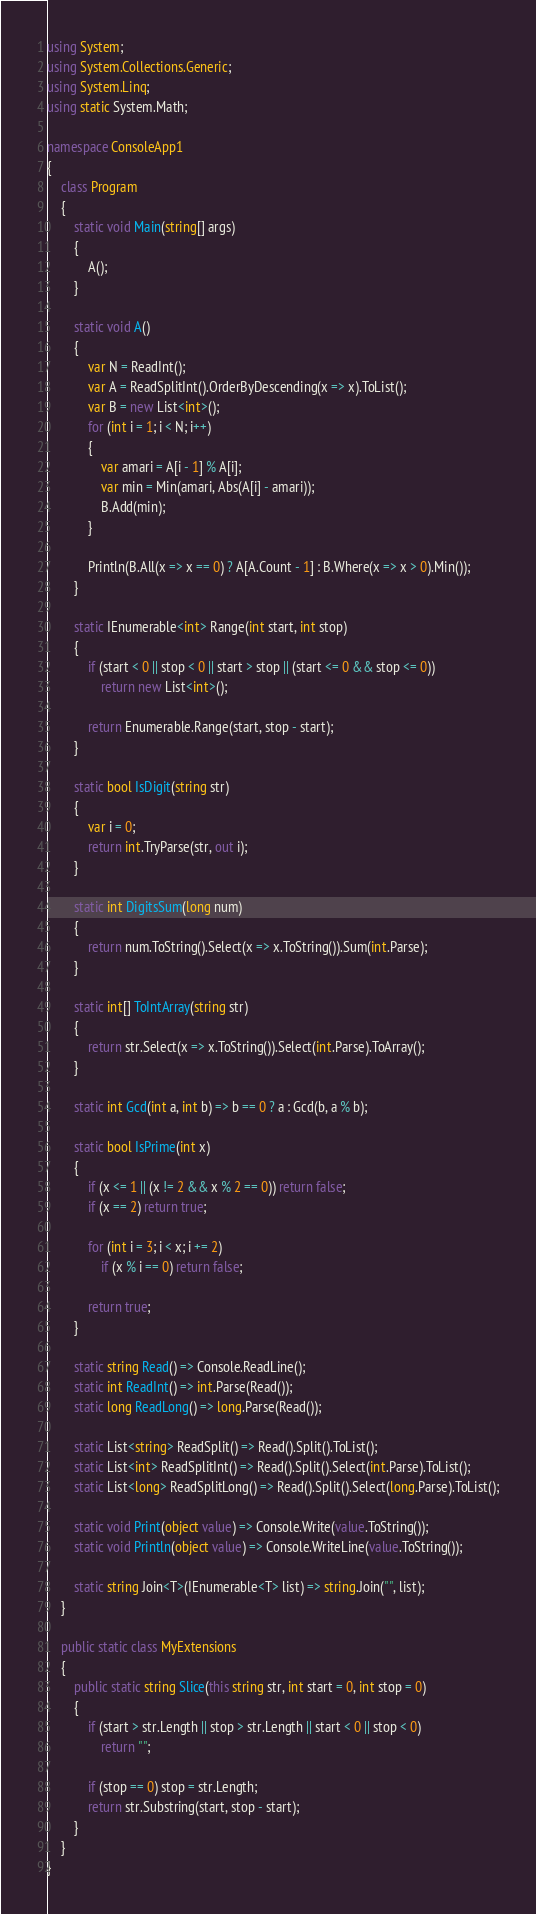Convert code to text. <code><loc_0><loc_0><loc_500><loc_500><_C#_>using System;
using System.Collections.Generic;
using System.Linq;
using static System.Math;

namespace ConsoleApp1
{
    class Program
    {
        static void Main(string[] args)
        {
            A();
        }

        static void A()
        {
            var N = ReadInt();
            var A = ReadSplitInt().OrderByDescending(x => x).ToList();
            var B = new List<int>();
            for (int i = 1; i < N; i++)
            {
                var amari = A[i - 1] % A[i];
                var min = Min(amari, Abs(A[i] - amari));
                B.Add(min);
            }

            Println(B.All(x => x == 0) ? A[A.Count - 1] : B.Where(x => x > 0).Min());
        }

        static IEnumerable<int> Range(int start, int stop)
        {
            if (start < 0 || stop < 0 || start > stop || (start <= 0 && stop <= 0))
                return new List<int>();

            return Enumerable.Range(start, stop - start);
        }

        static bool IsDigit(string str)
        {
            var i = 0;
            return int.TryParse(str, out i);
        }

        static int DigitsSum(long num)
        {
            return num.ToString().Select(x => x.ToString()).Sum(int.Parse);
        }

        static int[] ToIntArray(string str)
        {
            return str.Select(x => x.ToString()).Select(int.Parse).ToArray();
        }

        static int Gcd(int a, int b) => b == 0 ? a : Gcd(b, a % b);

        static bool IsPrime(int x)
        {
            if (x <= 1 || (x != 2 && x % 2 == 0)) return false;
            if (x == 2) return true;

            for (int i = 3; i < x; i += 2)
                if (x % i == 0) return false;

            return true;
        }

        static string Read() => Console.ReadLine();
        static int ReadInt() => int.Parse(Read());
        static long ReadLong() => long.Parse(Read());

        static List<string> ReadSplit() => Read().Split().ToList();
        static List<int> ReadSplitInt() => Read().Split().Select(int.Parse).ToList();
        static List<long> ReadSplitLong() => Read().Split().Select(long.Parse).ToList();

        static void Print(object value) => Console.Write(value.ToString());
        static void Println(object value) => Console.WriteLine(value.ToString());

        static string Join<T>(IEnumerable<T> list) => string.Join("", list);
    }

    public static class MyExtensions
    {
        public static string Slice(this string str, int start = 0, int stop = 0)
        {
            if (start > str.Length || stop > str.Length || start < 0 || stop < 0)
                return "";

            if (stop == 0) stop = str.Length;
            return str.Substring(start, stop - start);
        }
    }
}
</code> 